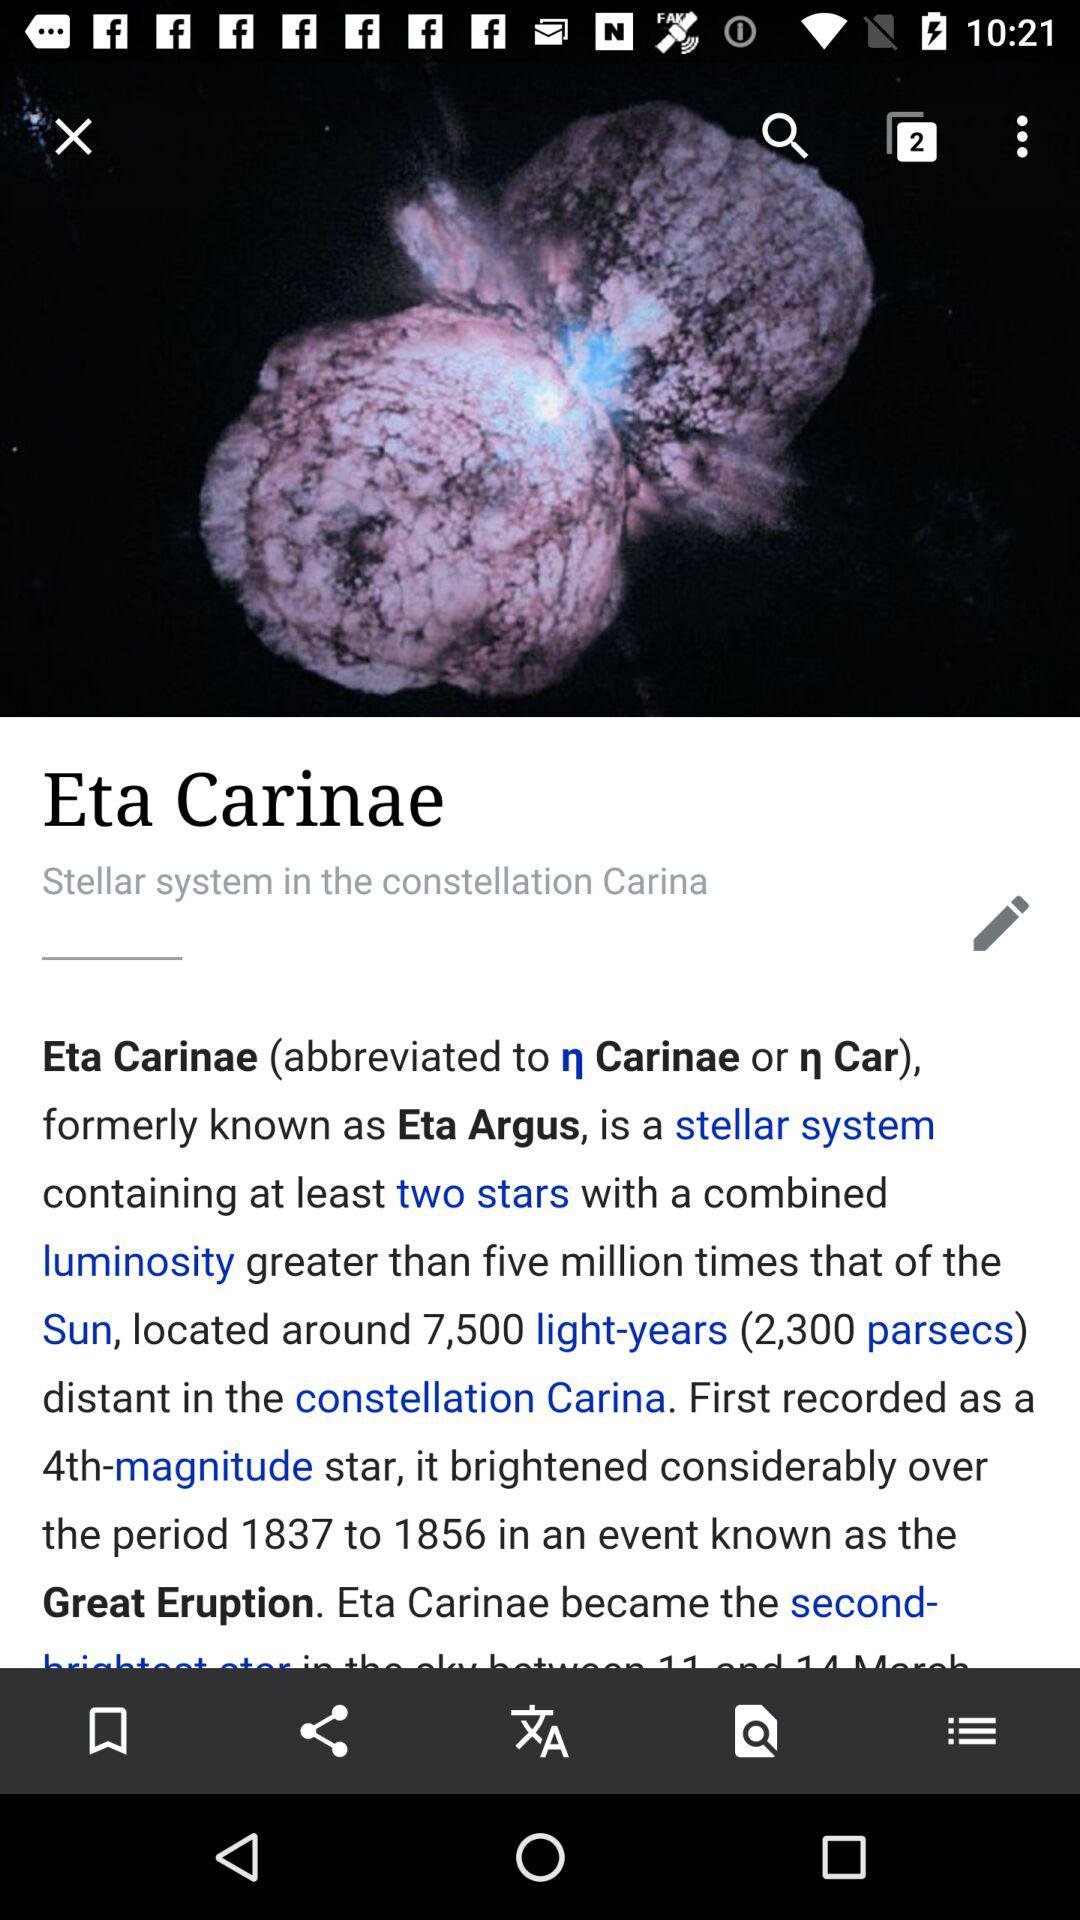What is Eta Carinae formally known as? Eta Carinae, formally known as Eta Argus. 